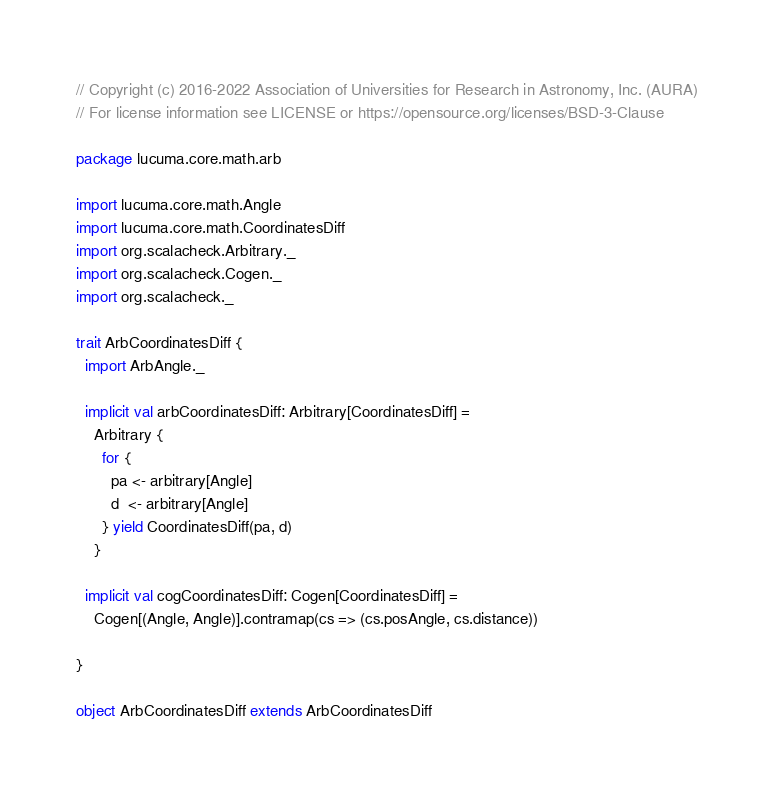Convert code to text. <code><loc_0><loc_0><loc_500><loc_500><_Scala_>// Copyright (c) 2016-2022 Association of Universities for Research in Astronomy, Inc. (AURA)
// For license information see LICENSE or https://opensource.org/licenses/BSD-3-Clause

package lucuma.core.math.arb

import lucuma.core.math.Angle
import lucuma.core.math.CoordinatesDiff
import org.scalacheck.Arbitrary._
import org.scalacheck.Cogen._
import org.scalacheck._

trait ArbCoordinatesDiff {
  import ArbAngle._

  implicit val arbCoordinatesDiff: Arbitrary[CoordinatesDiff] =
    Arbitrary {
      for {
        pa <- arbitrary[Angle]
        d  <- arbitrary[Angle]
      } yield CoordinatesDiff(pa, d)
    }

  implicit val cogCoordinatesDiff: Cogen[CoordinatesDiff] =
    Cogen[(Angle, Angle)].contramap(cs => (cs.posAngle, cs.distance))

}

object ArbCoordinatesDiff extends ArbCoordinatesDiff
</code> 